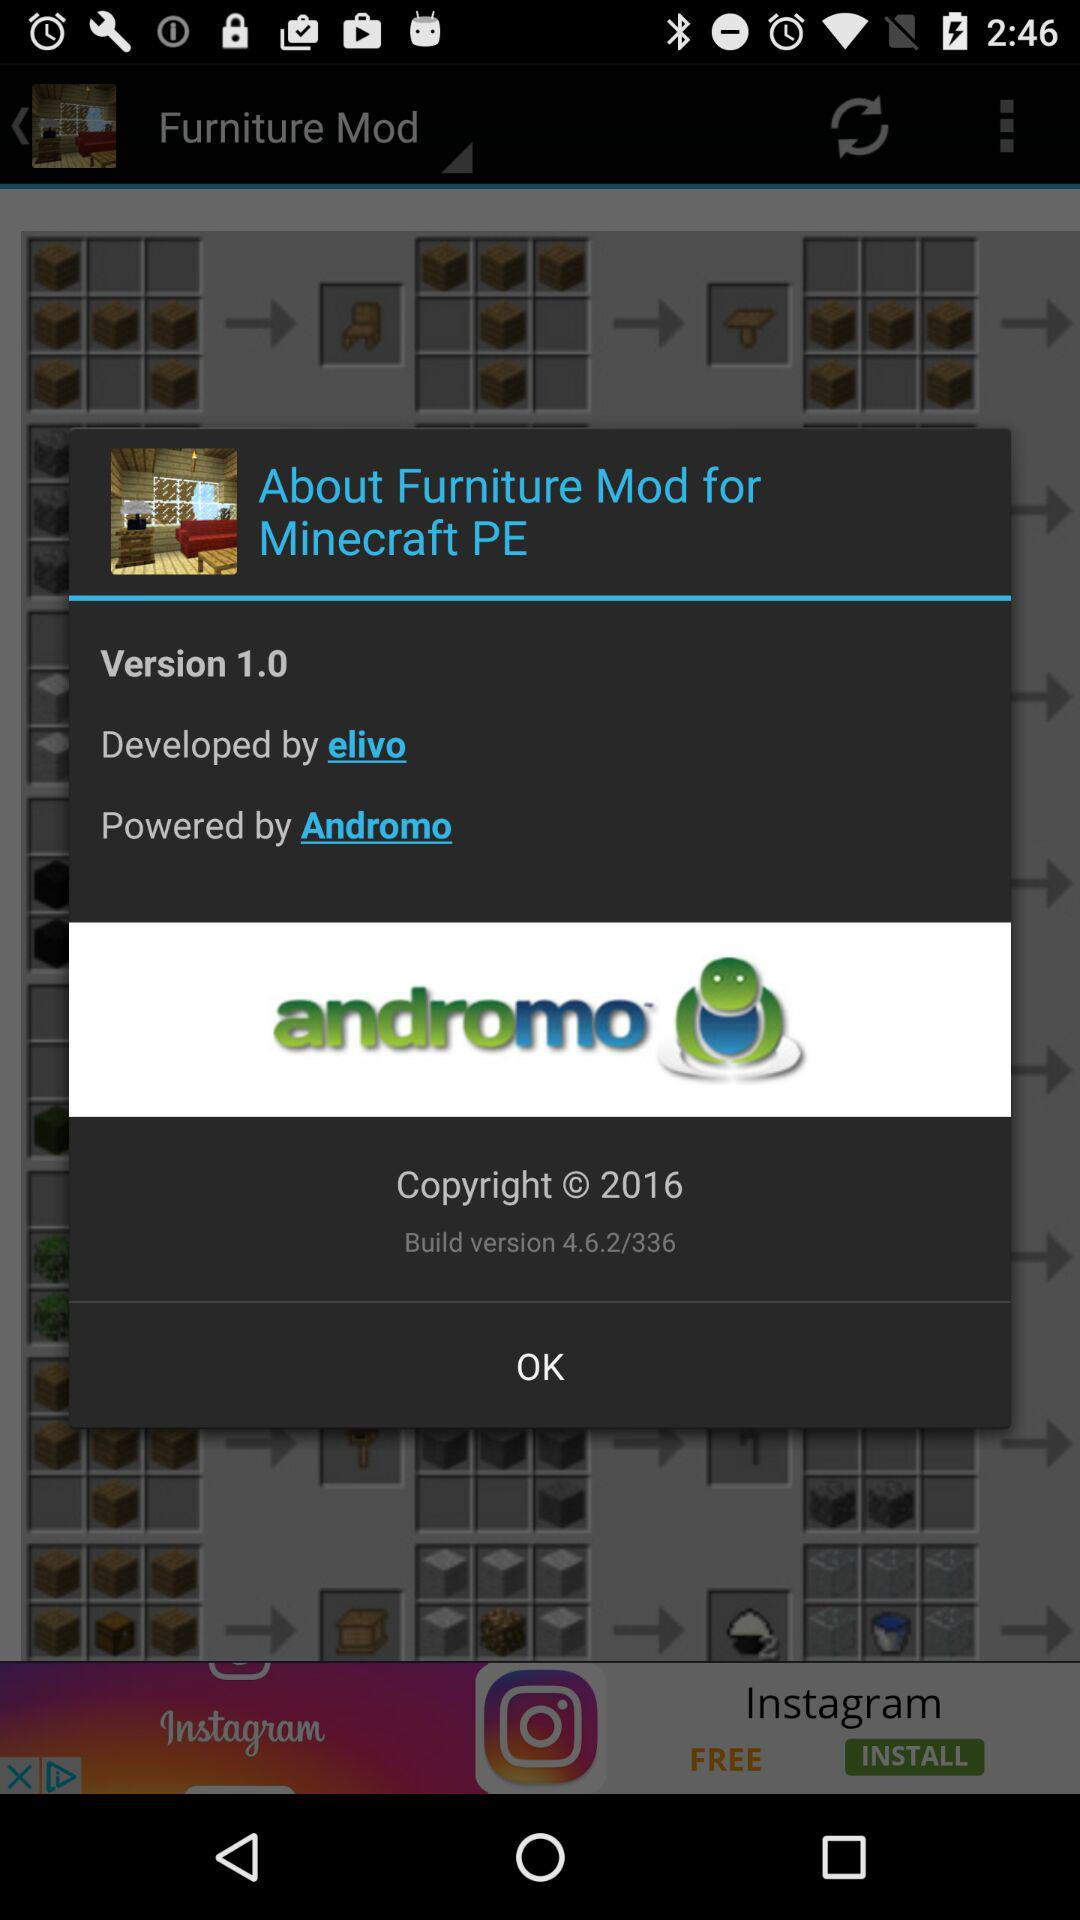Who developed "Furniture Mod"? It was developed by "elivo". 